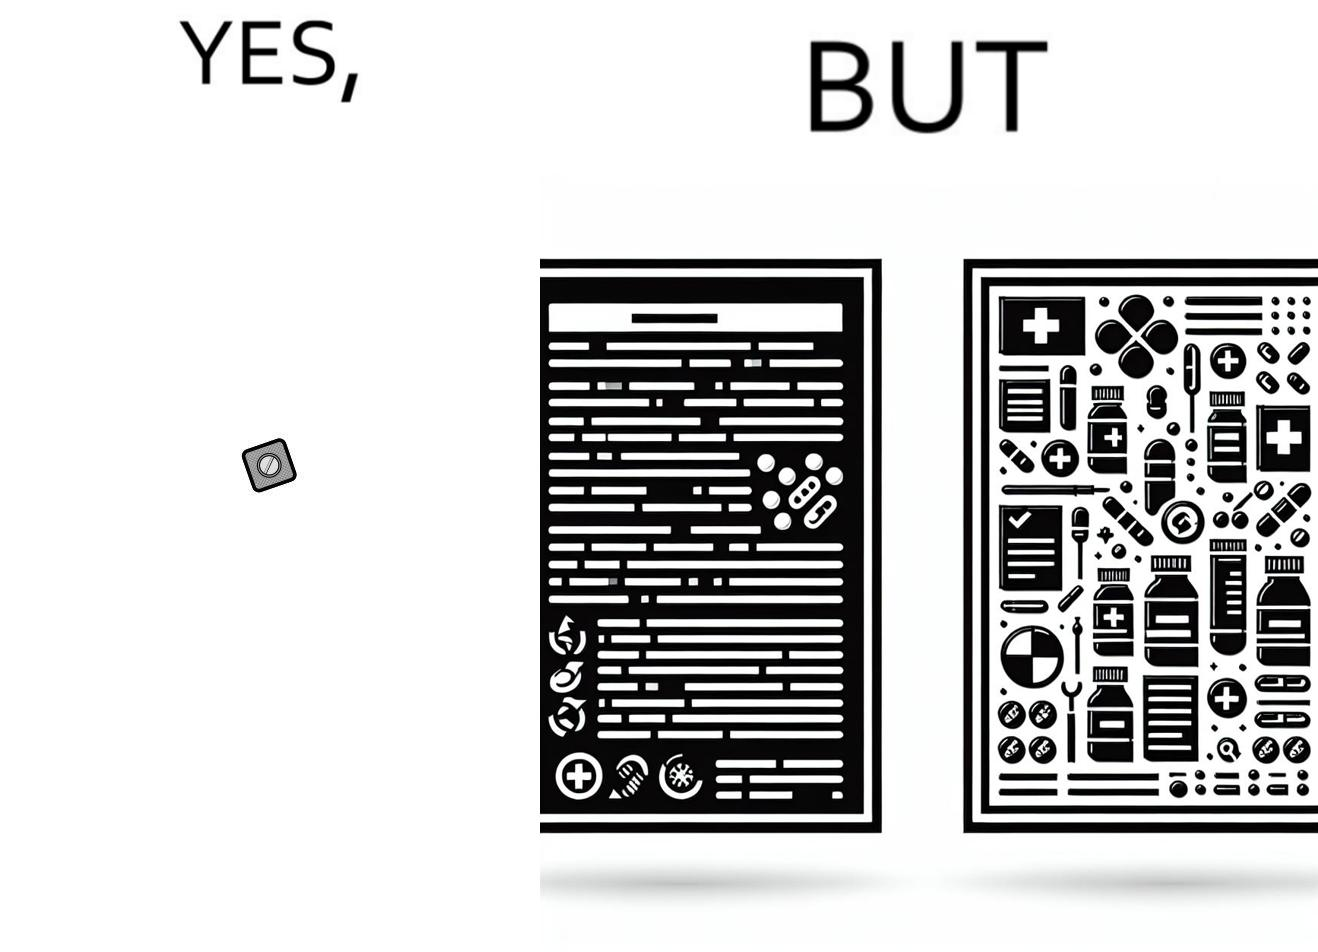Is this a satirical image? Yes, this image is satirical. 